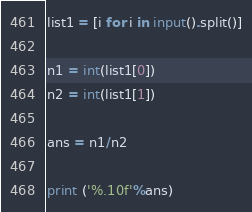Convert code to text. <code><loc_0><loc_0><loc_500><loc_500><_Python_>list1 = [i for i in input().split()]

n1 = int(list1[0])
n2 = int(list1[1])

ans = n1/n2

print ('%.10f'%ans)
</code> 